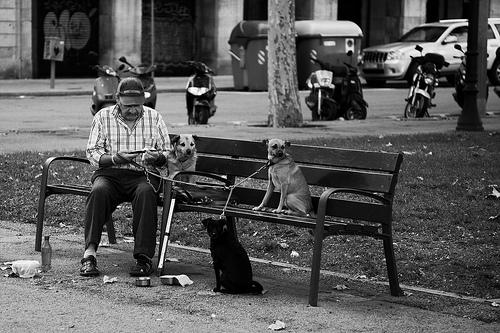State the primary activity happening in the image and the characters involved. A man is intently observing an object he's holding, with dogs sitting around him on a bench. Write a quick snapshot of what's happening in the picture. A man sits on a bench with dogs, focusing on an object he's holding. Mention the most prominent object or subject in the image and its action. A man is sitting on a bench with dogs and looking down at something in his hand. Compose a concise description of the main scene and events in the picture. A man surrounded by dogs, seated on a bench, attentively examining an item in his hand. Highlight the main subject of the image and their actions. The man on the bench is the central figure, engaged in studying an object in his hands, with dogs around him. Describe the key elements of the image in one sentence. A man in a checkered shirt sits on a wooden bench, next to dogs, observing an item in his hand. Briefly describe the central subject and their activity in the image. The image features a man on a bench, engrossed in inspecting an object in his hand, with dogs nearby. Write a one-sentence summary of the main actions happening in the image. A man seated on a park bench is closely inspecting an item while being surrounded by three dogs. What is the most noticeable event happening in the photograph? An older man sitting on a bench, examining an object in his hand, with several dogs nearby. Briefly explain the condition and content of the photo. The image shows an elderly man sitting on a roadside bench, surrounded by dogs and looking at an object in his hand. 